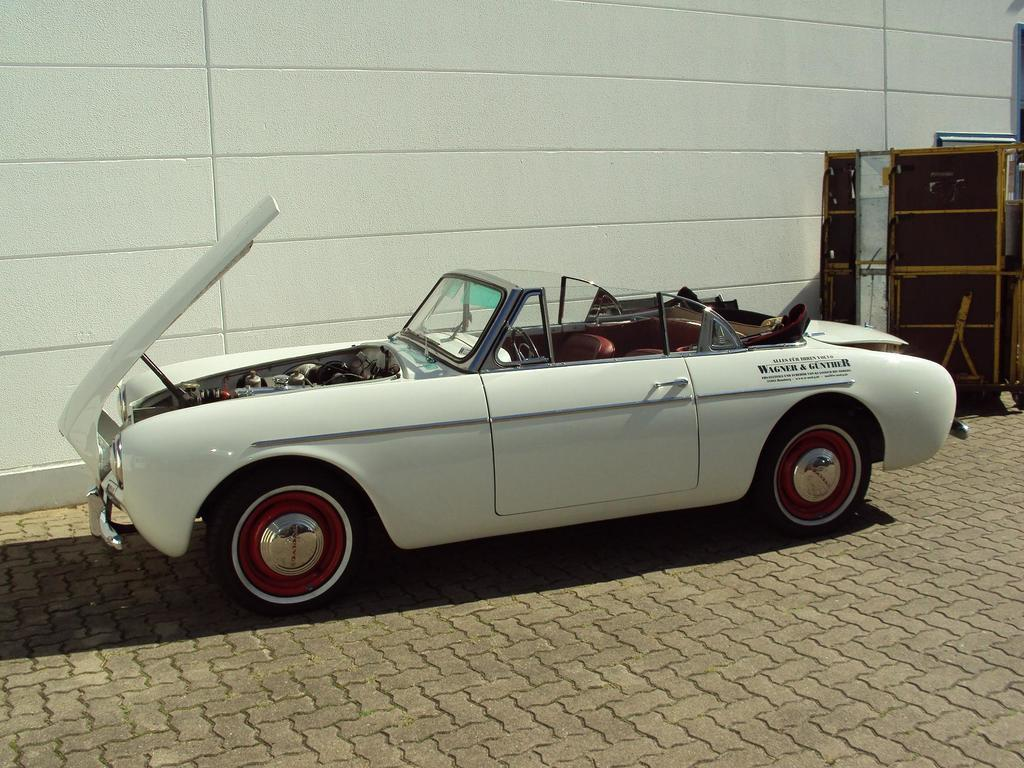What color is the car in the image? The car in the image is white-colored. What is the position of the car's bonnet in the image? The car's bonnet is opened in the image. Can you describe what is present behind the car in the image? Unfortunately, the provided facts do not give any information about what is present behind the car. What type of coastline can be seen in the image? There is no coastline present in the image; it features a white-colored car with its bonnet opened. 